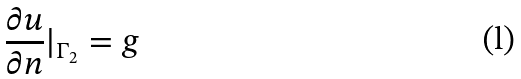Convert formula to latex. <formula><loc_0><loc_0><loc_500><loc_500>\frac { \partial u } { \partial n } | _ { \Gamma _ { 2 } } = g</formula> 